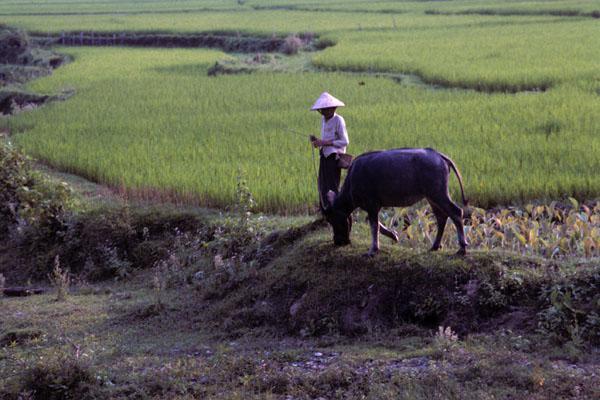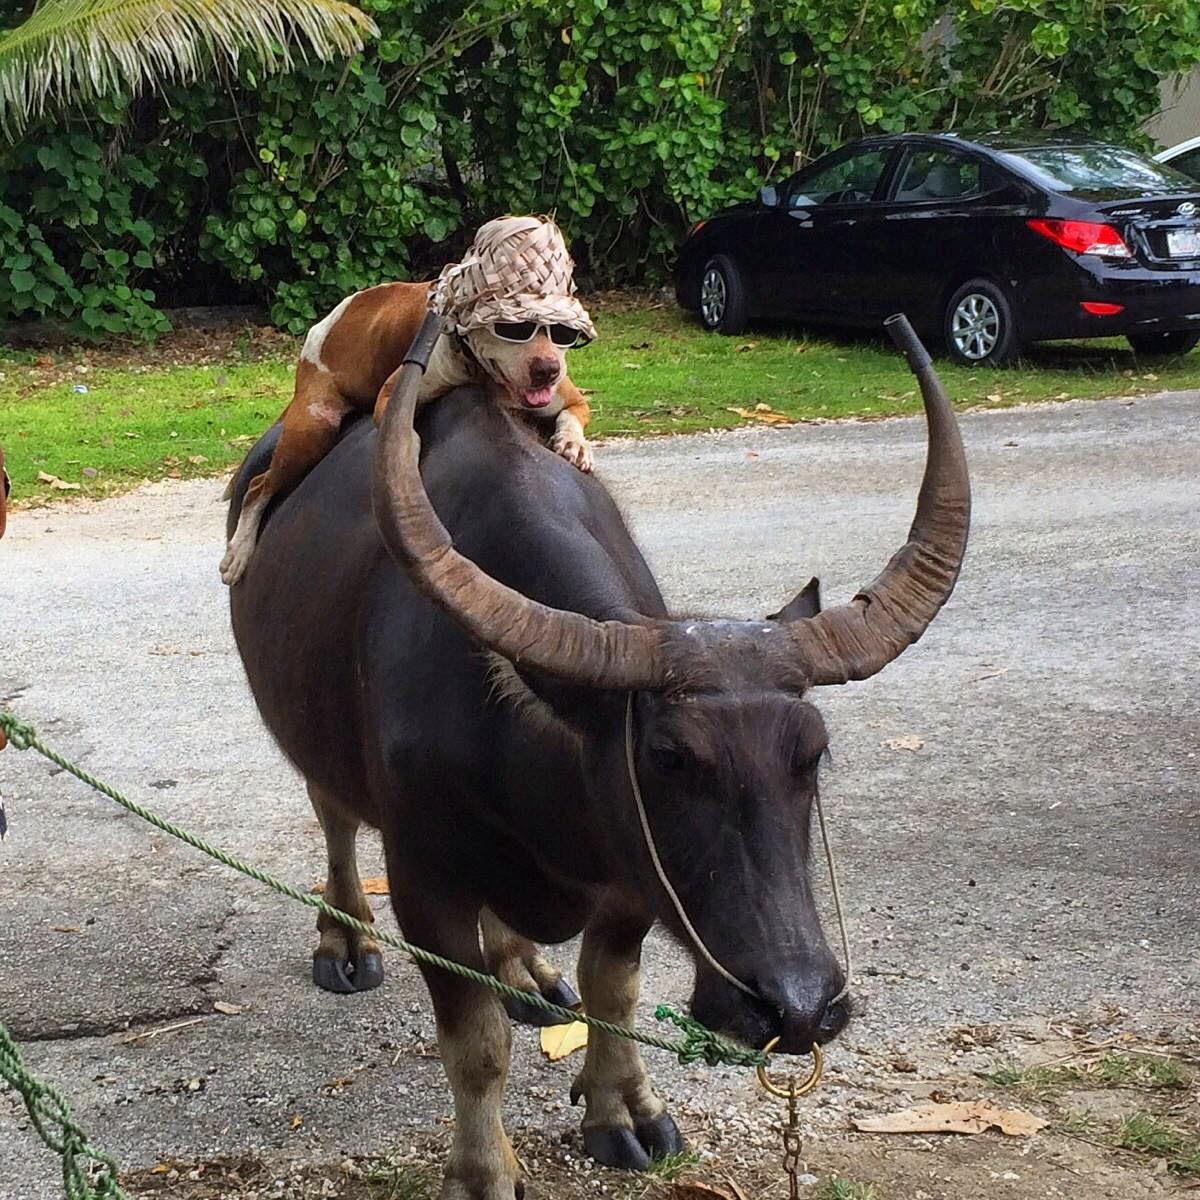The first image is the image on the left, the second image is the image on the right. For the images shown, is this caption "A small boy straddles a horned cow in the image on the left." true? Answer yes or no. No. The first image is the image on the left, the second image is the image on the right. Analyze the images presented: Is the assertion "Each image features a young boy on top of a water buffalo's back, but only the left image shows a boy sitting with his legs dangling over the sides of the animal." valid? Answer yes or no. No. 